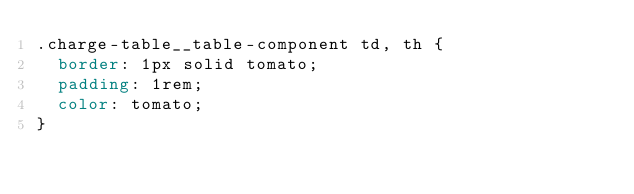<code> <loc_0><loc_0><loc_500><loc_500><_CSS_>.charge-table__table-component td, th {
  border: 1px solid tomato;
  padding: 1rem;
  color: tomato;
}
</code> 